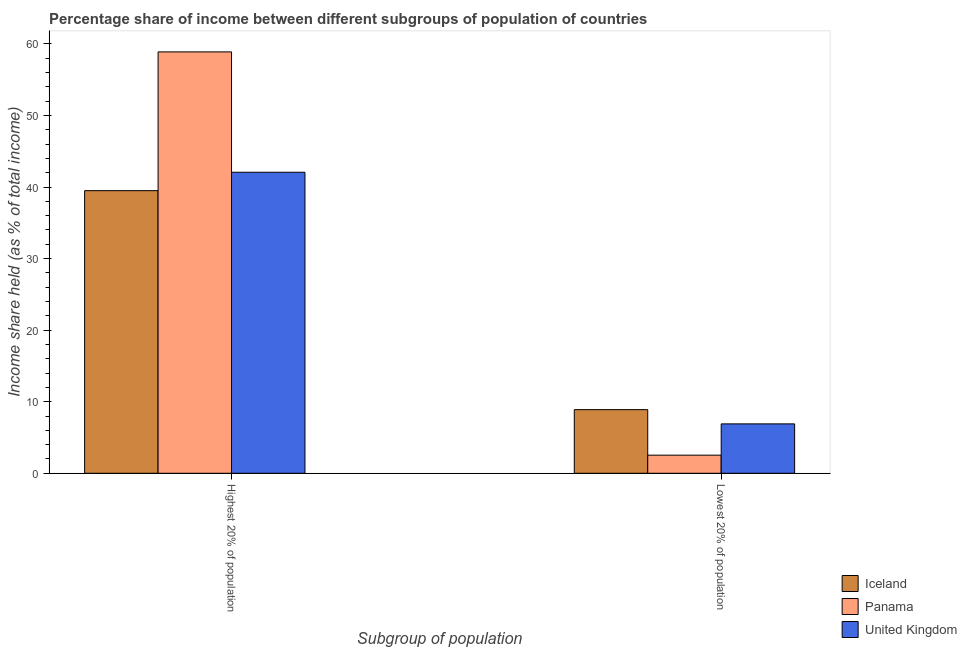How many groups of bars are there?
Offer a very short reply. 2. Are the number of bars per tick equal to the number of legend labels?
Give a very brief answer. Yes. Are the number of bars on each tick of the X-axis equal?
Your answer should be compact. Yes. How many bars are there on the 2nd tick from the right?
Give a very brief answer. 3. What is the label of the 1st group of bars from the left?
Your response must be concise. Highest 20% of population. Across all countries, what is the maximum income share held by highest 20% of the population?
Offer a very short reply. 58.88. Across all countries, what is the minimum income share held by highest 20% of the population?
Offer a terse response. 39.49. In which country was the income share held by lowest 20% of the population minimum?
Provide a succinct answer. Panama. What is the total income share held by highest 20% of the population in the graph?
Your response must be concise. 140.43. What is the difference between the income share held by highest 20% of the population in United Kingdom and that in Iceland?
Your answer should be very brief. 2.57. What is the difference between the income share held by lowest 20% of the population in Iceland and the income share held by highest 20% of the population in Panama?
Ensure brevity in your answer.  -49.99. What is the average income share held by highest 20% of the population per country?
Your answer should be compact. 46.81. What is the difference between the income share held by highest 20% of the population and income share held by lowest 20% of the population in United Kingdom?
Offer a terse response. 35.16. In how many countries, is the income share held by lowest 20% of the population greater than 56 %?
Provide a succinct answer. 0. What is the ratio of the income share held by lowest 20% of the population in United Kingdom to that in Panama?
Make the answer very short. 2.73. Is the income share held by highest 20% of the population in Iceland less than that in Panama?
Keep it short and to the point. Yes. What does the 3rd bar from the left in Highest 20% of population represents?
Keep it short and to the point. United Kingdom. How many bars are there?
Your answer should be very brief. 6. Are all the bars in the graph horizontal?
Offer a terse response. No. What is the difference between two consecutive major ticks on the Y-axis?
Your response must be concise. 10. Are the values on the major ticks of Y-axis written in scientific E-notation?
Provide a short and direct response. No. Does the graph contain any zero values?
Your answer should be compact. No. Where does the legend appear in the graph?
Offer a very short reply. Bottom right. How many legend labels are there?
Ensure brevity in your answer.  3. What is the title of the graph?
Your answer should be very brief. Percentage share of income between different subgroups of population of countries. What is the label or title of the X-axis?
Give a very brief answer. Subgroup of population. What is the label or title of the Y-axis?
Keep it short and to the point. Income share held (as % of total income). What is the Income share held (as % of total income) in Iceland in Highest 20% of population?
Your response must be concise. 39.49. What is the Income share held (as % of total income) in Panama in Highest 20% of population?
Ensure brevity in your answer.  58.88. What is the Income share held (as % of total income) in United Kingdom in Highest 20% of population?
Your response must be concise. 42.06. What is the Income share held (as % of total income) in Iceland in Lowest 20% of population?
Provide a short and direct response. 8.89. What is the Income share held (as % of total income) in Panama in Lowest 20% of population?
Keep it short and to the point. 2.53. What is the Income share held (as % of total income) in United Kingdom in Lowest 20% of population?
Provide a succinct answer. 6.9. Across all Subgroup of population, what is the maximum Income share held (as % of total income) of Iceland?
Provide a succinct answer. 39.49. Across all Subgroup of population, what is the maximum Income share held (as % of total income) in Panama?
Offer a terse response. 58.88. Across all Subgroup of population, what is the maximum Income share held (as % of total income) of United Kingdom?
Provide a succinct answer. 42.06. Across all Subgroup of population, what is the minimum Income share held (as % of total income) of Iceland?
Offer a terse response. 8.89. Across all Subgroup of population, what is the minimum Income share held (as % of total income) of Panama?
Offer a very short reply. 2.53. What is the total Income share held (as % of total income) of Iceland in the graph?
Your answer should be very brief. 48.38. What is the total Income share held (as % of total income) of Panama in the graph?
Provide a short and direct response. 61.41. What is the total Income share held (as % of total income) of United Kingdom in the graph?
Offer a very short reply. 48.96. What is the difference between the Income share held (as % of total income) of Iceland in Highest 20% of population and that in Lowest 20% of population?
Make the answer very short. 30.6. What is the difference between the Income share held (as % of total income) in Panama in Highest 20% of population and that in Lowest 20% of population?
Offer a very short reply. 56.35. What is the difference between the Income share held (as % of total income) of United Kingdom in Highest 20% of population and that in Lowest 20% of population?
Keep it short and to the point. 35.16. What is the difference between the Income share held (as % of total income) of Iceland in Highest 20% of population and the Income share held (as % of total income) of Panama in Lowest 20% of population?
Keep it short and to the point. 36.96. What is the difference between the Income share held (as % of total income) in Iceland in Highest 20% of population and the Income share held (as % of total income) in United Kingdom in Lowest 20% of population?
Make the answer very short. 32.59. What is the difference between the Income share held (as % of total income) of Panama in Highest 20% of population and the Income share held (as % of total income) of United Kingdom in Lowest 20% of population?
Your answer should be compact. 51.98. What is the average Income share held (as % of total income) in Iceland per Subgroup of population?
Provide a succinct answer. 24.19. What is the average Income share held (as % of total income) in Panama per Subgroup of population?
Provide a succinct answer. 30.7. What is the average Income share held (as % of total income) in United Kingdom per Subgroup of population?
Your response must be concise. 24.48. What is the difference between the Income share held (as % of total income) in Iceland and Income share held (as % of total income) in Panama in Highest 20% of population?
Provide a succinct answer. -19.39. What is the difference between the Income share held (as % of total income) of Iceland and Income share held (as % of total income) of United Kingdom in Highest 20% of population?
Keep it short and to the point. -2.57. What is the difference between the Income share held (as % of total income) in Panama and Income share held (as % of total income) in United Kingdom in Highest 20% of population?
Ensure brevity in your answer.  16.82. What is the difference between the Income share held (as % of total income) of Iceland and Income share held (as % of total income) of Panama in Lowest 20% of population?
Make the answer very short. 6.36. What is the difference between the Income share held (as % of total income) of Iceland and Income share held (as % of total income) of United Kingdom in Lowest 20% of population?
Keep it short and to the point. 1.99. What is the difference between the Income share held (as % of total income) in Panama and Income share held (as % of total income) in United Kingdom in Lowest 20% of population?
Ensure brevity in your answer.  -4.37. What is the ratio of the Income share held (as % of total income) in Iceland in Highest 20% of population to that in Lowest 20% of population?
Your response must be concise. 4.44. What is the ratio of the Income share held (as % of total income) in Panama in Highest 20% of population to that in Lowest 20% of population?
Offer a very short reply. 23.27. What is the ratio of the Income share held (as % of total income) of United Kingdom in Highest 20% of population to that in Lowest 20% of population?
Your answer should be compact. 6.1. What is the difference between the highest and the second highest Income share held (as % of total income) in Iceland?
Your answer should be compact. 30.6. What is the difference between the highest and the second highest Income share held (as % of total income) of Panama?
Give a very brief answer. 56.35. What is the difference between the highest and the second highest Income share held (as % of total income) of United Kingdom?
Keep it short and to the point. 35.16. What is the difference between the highest and the lowest Income share held (as % of total income) of Iceland?
Ensure brevity in your answer.  30.6. What is the difference between the highest and the lowest Income share held (as % of total income) in Panama?
Your answer should be very brief. 56.35. What is the difference between the highest and the lowest Income share held (as % of total income) of United Kingdom?
Ensure brevity in your answer.  35.16. 